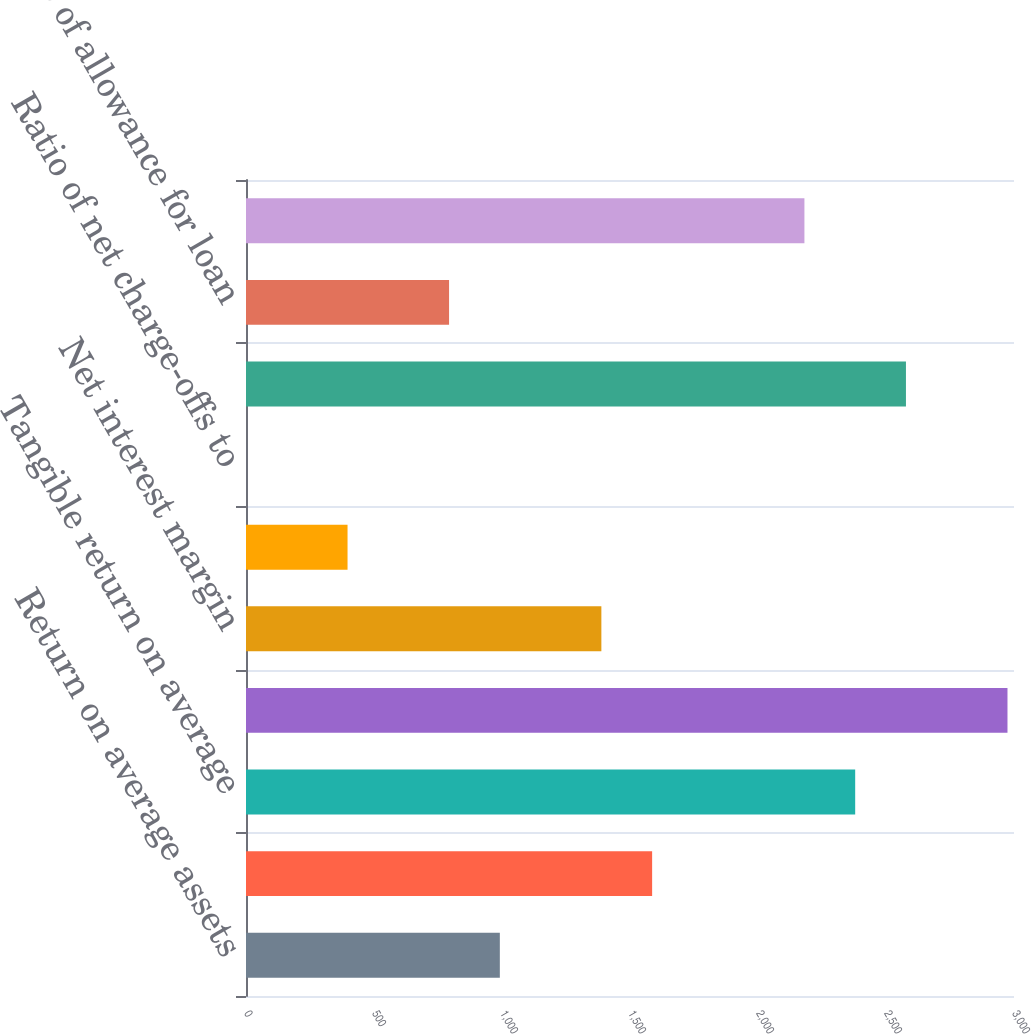Convert chart. <chart><loc_0><loc_0><loc_500><loc_500><bar_chart><fcel>Return on average assets<fcel>Return on average common<fcel>Tangible return on average<fcel>Efficiency ratio<fcel>Net interest margin<fcel>Net loan and lease charge-offs<fcel>Ratio of net charge-offs to<fcel>Allowance for loan losses<fcel>Ratio of allowance for loan<fcel>Nonperforming assets<nl><fcel>991.54<fcel>1586.44<fcel>2379.64<fcel>2974.54<fcel>1388.14<fcel>396.64<fcel>0.04<fcel>2577.94<fcel>793.24<fcel>2181.34<nl></chart> 